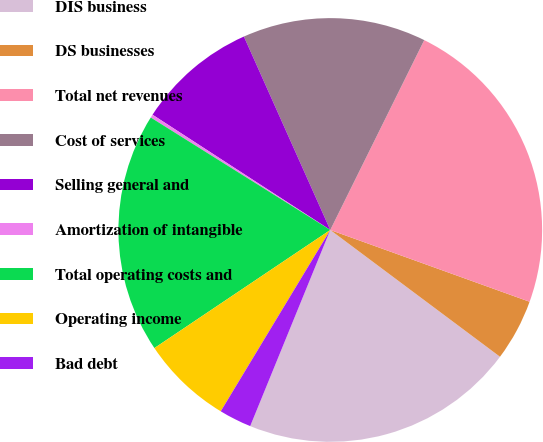Convert chart to OTSL. <chart><loc_0><loc_0><loc_500><loc_500><pie_chart><fcel>DIS business<fcel>DS businesses<fcel>Total net revenues<fcel>Cost of services<fcel>Selling general and<fcel>Amortization of intangible<fcel>Total operating costs and<fcel>Operating income<fcel>Bad debt<nl><fcel>20.96%<fcel>4.71%<fcel>23.19%<fcel>14.0%<fcel>9.16%<fcel>0.25%<fcel>18.32%<fcel>6.94%<fcel>2.48%<nl></chart> 